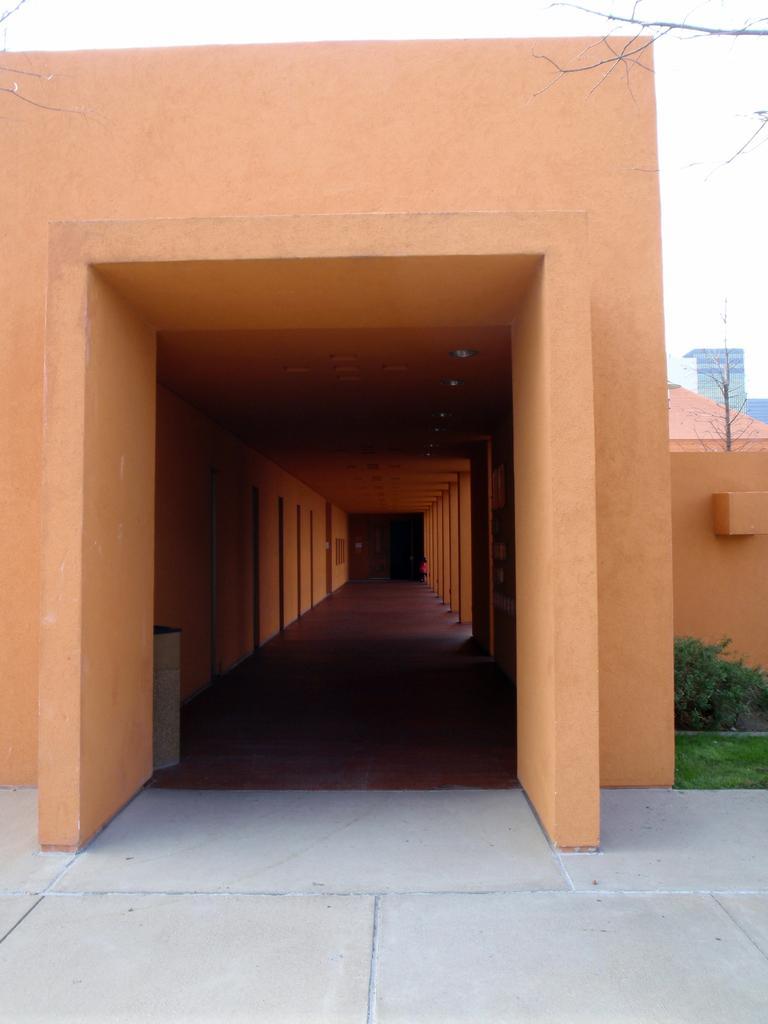How would you summarize this image in a sentence or two? In this image, this looks like a small building. I think these are the pillars. This looks like an object, which is at the corner of the image. I can see a small bush and the grass. In the background, I can see the buildings. 